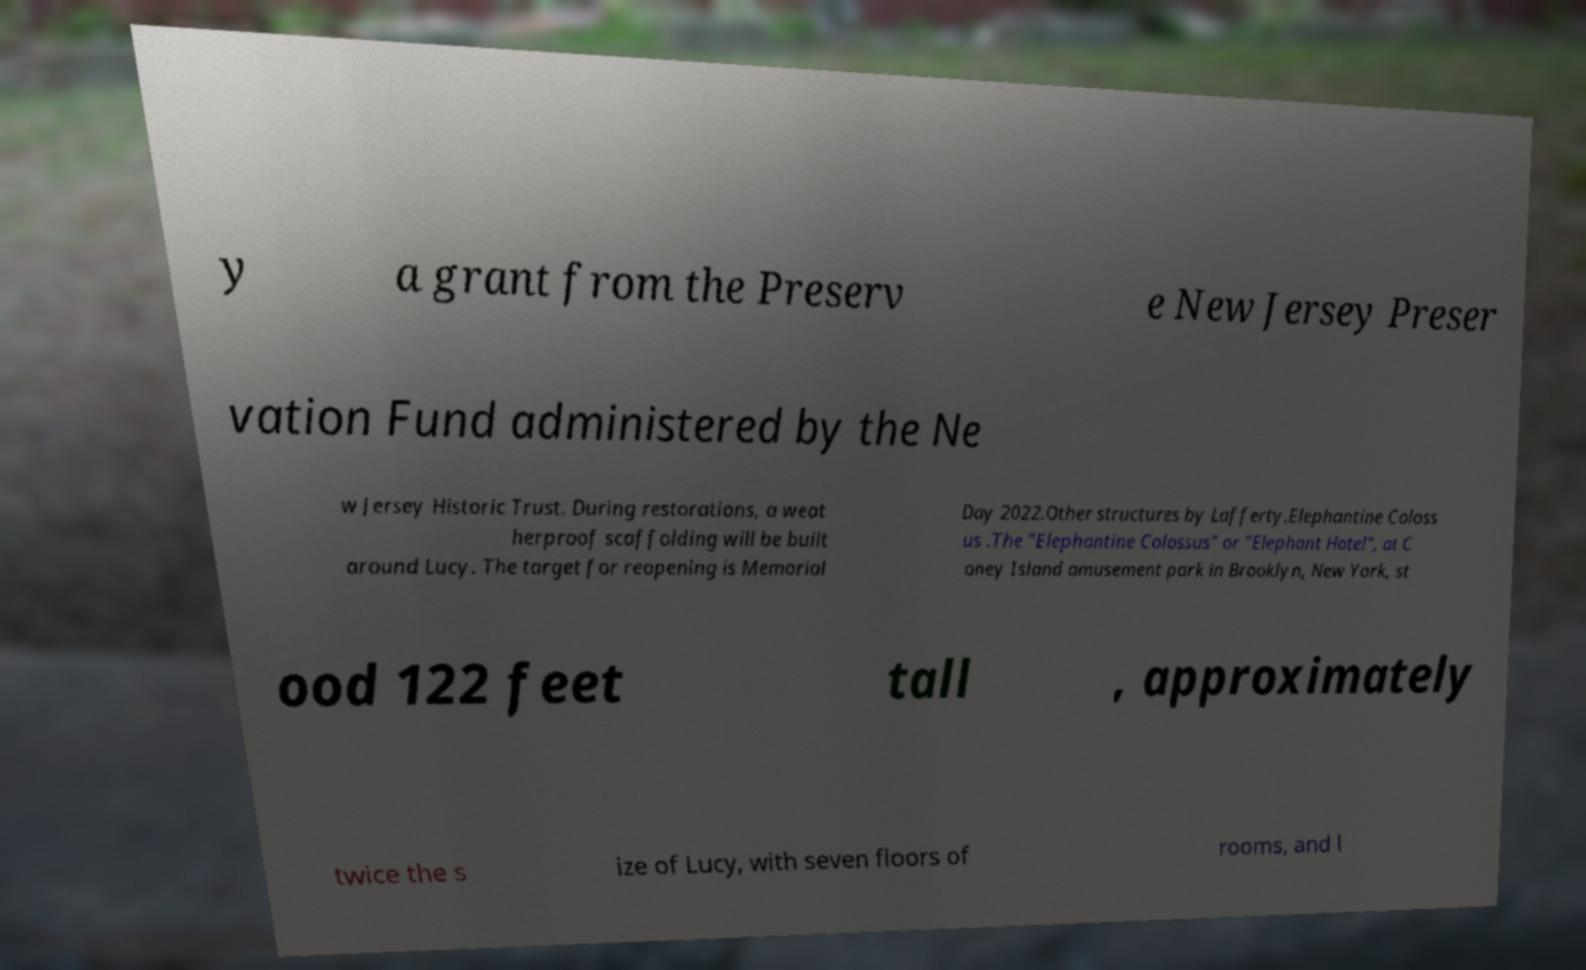There's text embedded in this image that I need extracted. Can you transcribe it verbatim? y a grant from the Preserv e New Jersey Preser vation Fund administered by the Ne w Jersey Historic Trust. During restorations, a weat herproof scaffolding will be built around Lucy. The target for reopening is Memorial Day 2022.Other structures by Lafferty.Elephantine Coloss us .The "Elephantine Colossus" or "Elephant Hotel", at C oney Island amusement park in Brooklyn, New York, st ood 122 feet tall , approximately twice the s ize of Lucy, with seven floors of rooms, and l 